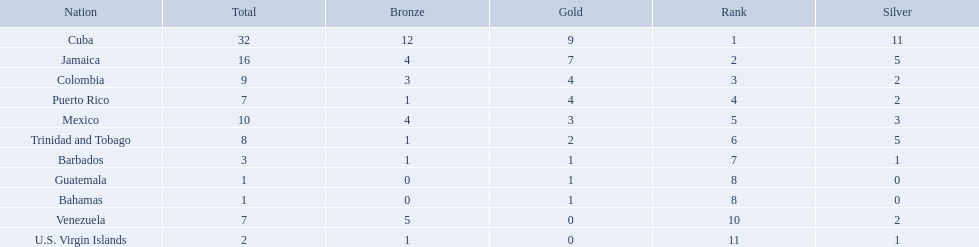Which teams have at exactly 4 gold medals? Colombia, Puerto Rico. Of those teams which has exactly 1 bronze medal? Puerto Rico. 